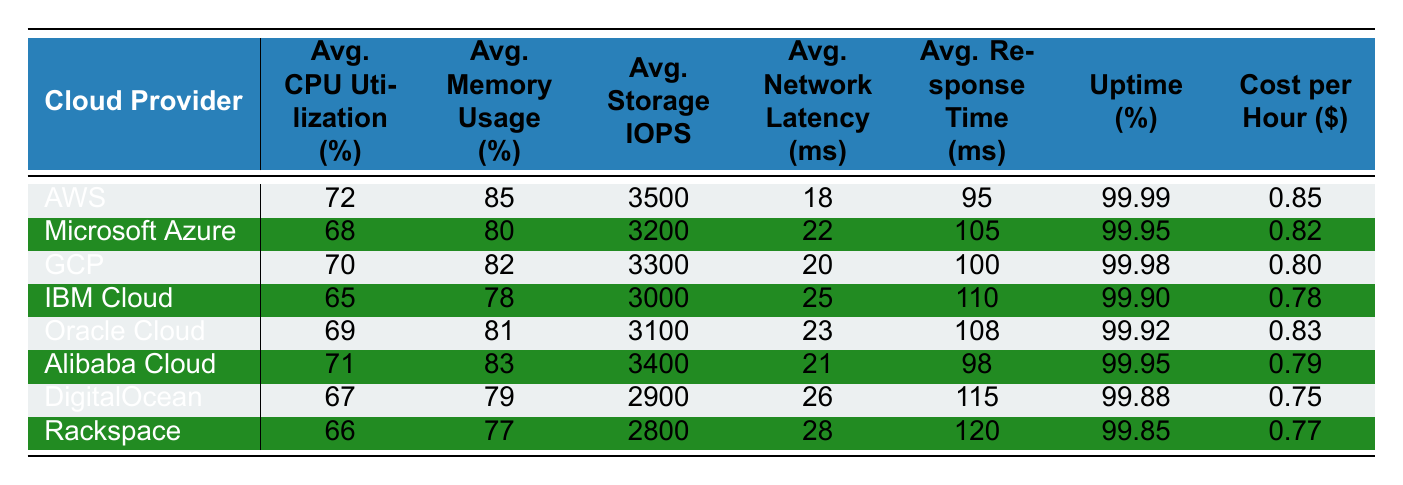What is the average CPU utilization for Amazon Web Services? The table shows that the average CPU utilization for Amazon Web Services is listed as 72%.
Answer: 72% Which cloud provider has the highest uptime percentage? By reviewing the uptime percentages listed, Amazon Web Services has the highest uptime at 99.99%.
Answer: Amazon Web Services What is the average response time for Microsoft Azure? The average response time for Microsoft Azure is 105 ms according to the table data.
Answer: 105 ms Which cloud provider has the lowest cost per hour? Checking the cost per hour column, DigitalOcean has the lowest cost at $0.75 per hour.
Answer: DigitalOcean What is the average storage IOPS for Google Cloud Platform? The table indicates that the average storage IOPS for Google Cloud Platform is 3300 IOPS.
Answer: 3300 IOPS Which cloud provider has an average network latency greater than 24 ms? Looking at the network latency values, both IBM Cloud (25 ms) and Rackspace (28 ms) have latencies greater than 24 ms.
Answer: IBM Cloud, Rackspace Calculate the average memory usage for all cloud providers. Summing up the average memory usage values gives (85 + 80 + 82 + 78 + 81 + 83 + 79 + 77) =  646. Dividing by the number of providers (8), we get 646 / 8 = 80.75%.
Answer: 80.75% Is Google's Cloud Platform more efficient in terms of average CPU utilization compared to IBM Cloud? Google Cloud Platform has an average CPU utilization of 70%, while IBM Cloud has 65%. Therefore, GCP is more efficient.
Answer: Yes Which cloud provider has the highest average network latency? The table indicates that Rackspace has the highest average network latency at 28 ms.
Answer: Rackspace If we consider uptime as a measure of reliability, which cloud provider would you recommend? Based on uptime percentages, Amazon Web Services, with 99.99%, is the most reliable choice.
Answer: Amazon Web Services 